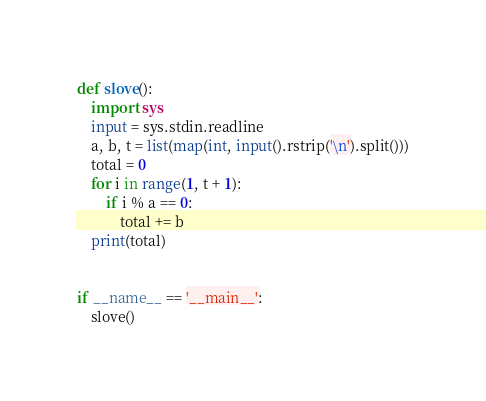<code> <loc_0><loc_0><loc_500><loc_500><_Python_>def slove():
    import sys
    input = sys.stdin.readline
    a, b, t = list(map(int, input().rstrip('\n').split()))
    total = 0
    for i in range(1, t + 1):
        if i % a == 0:
            total += b
    print(total)


if __name__ == '__main__':
    slove()
</code> 